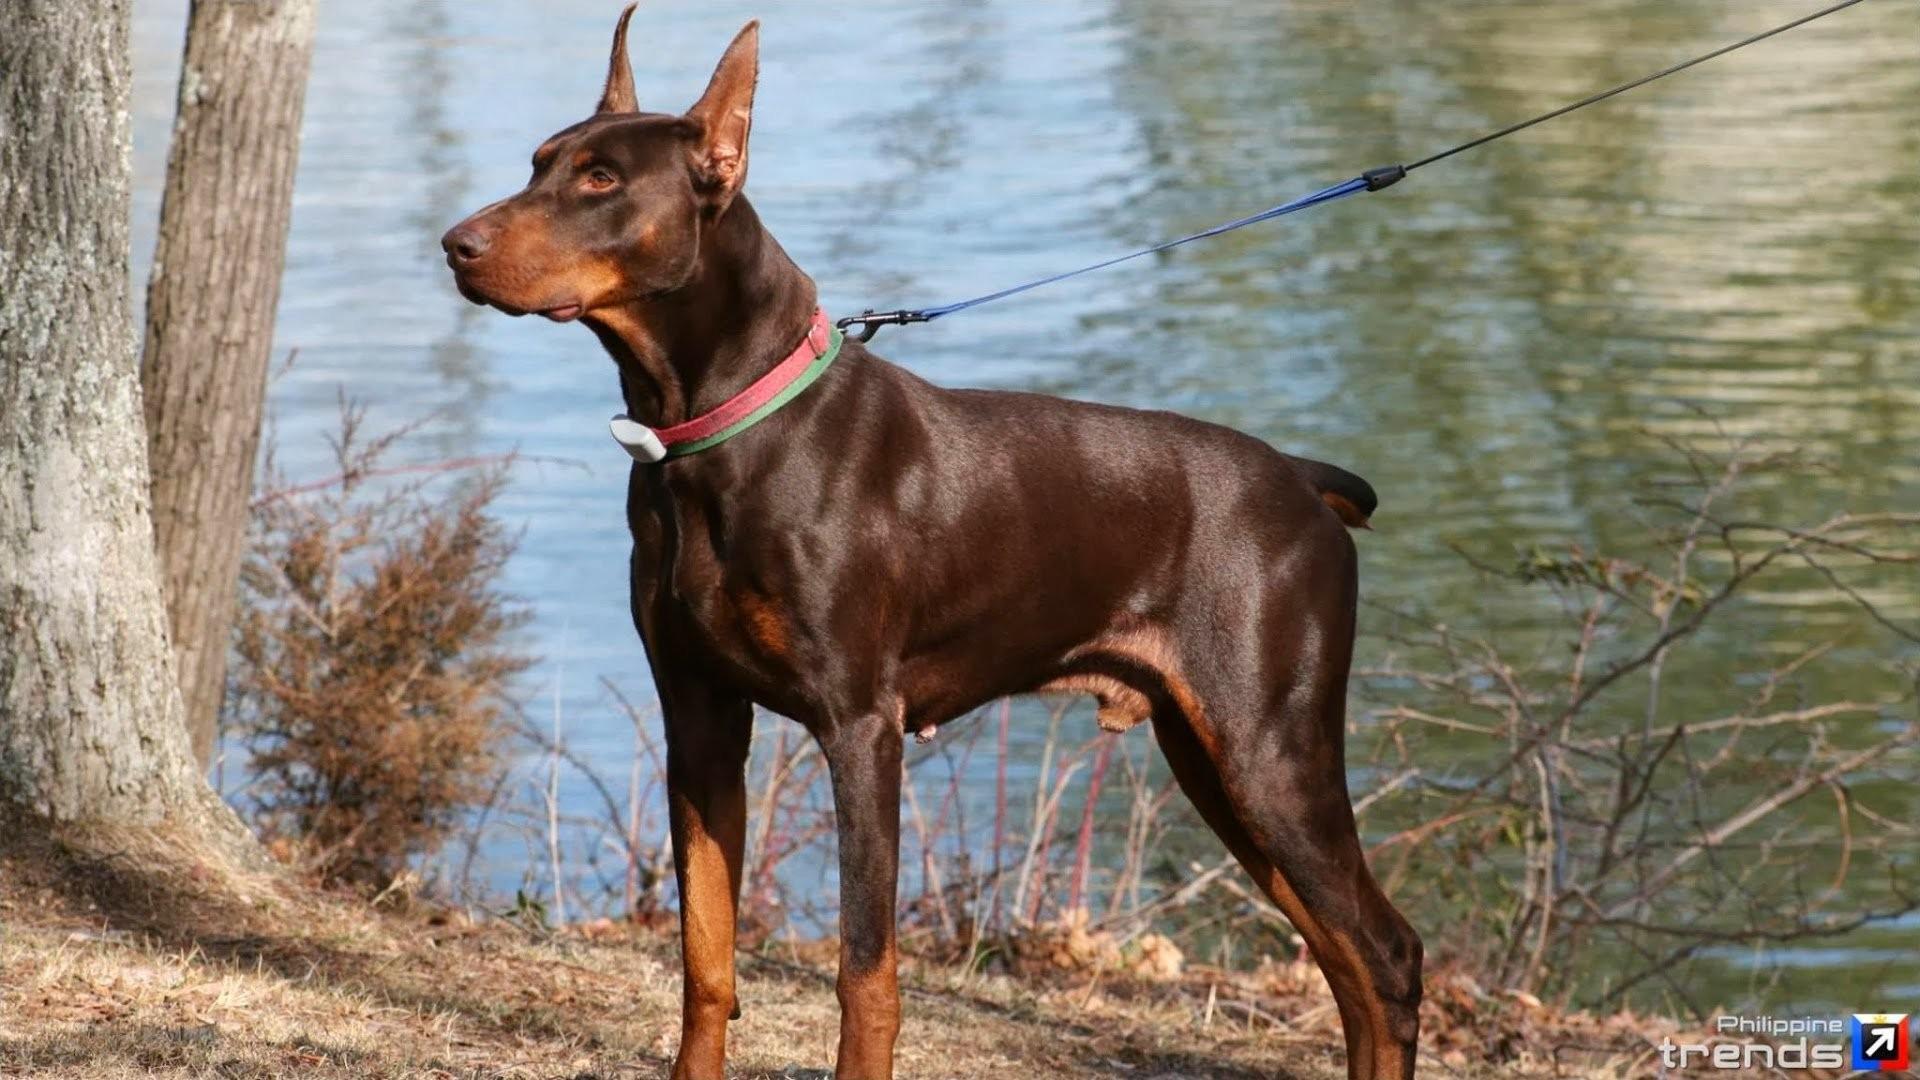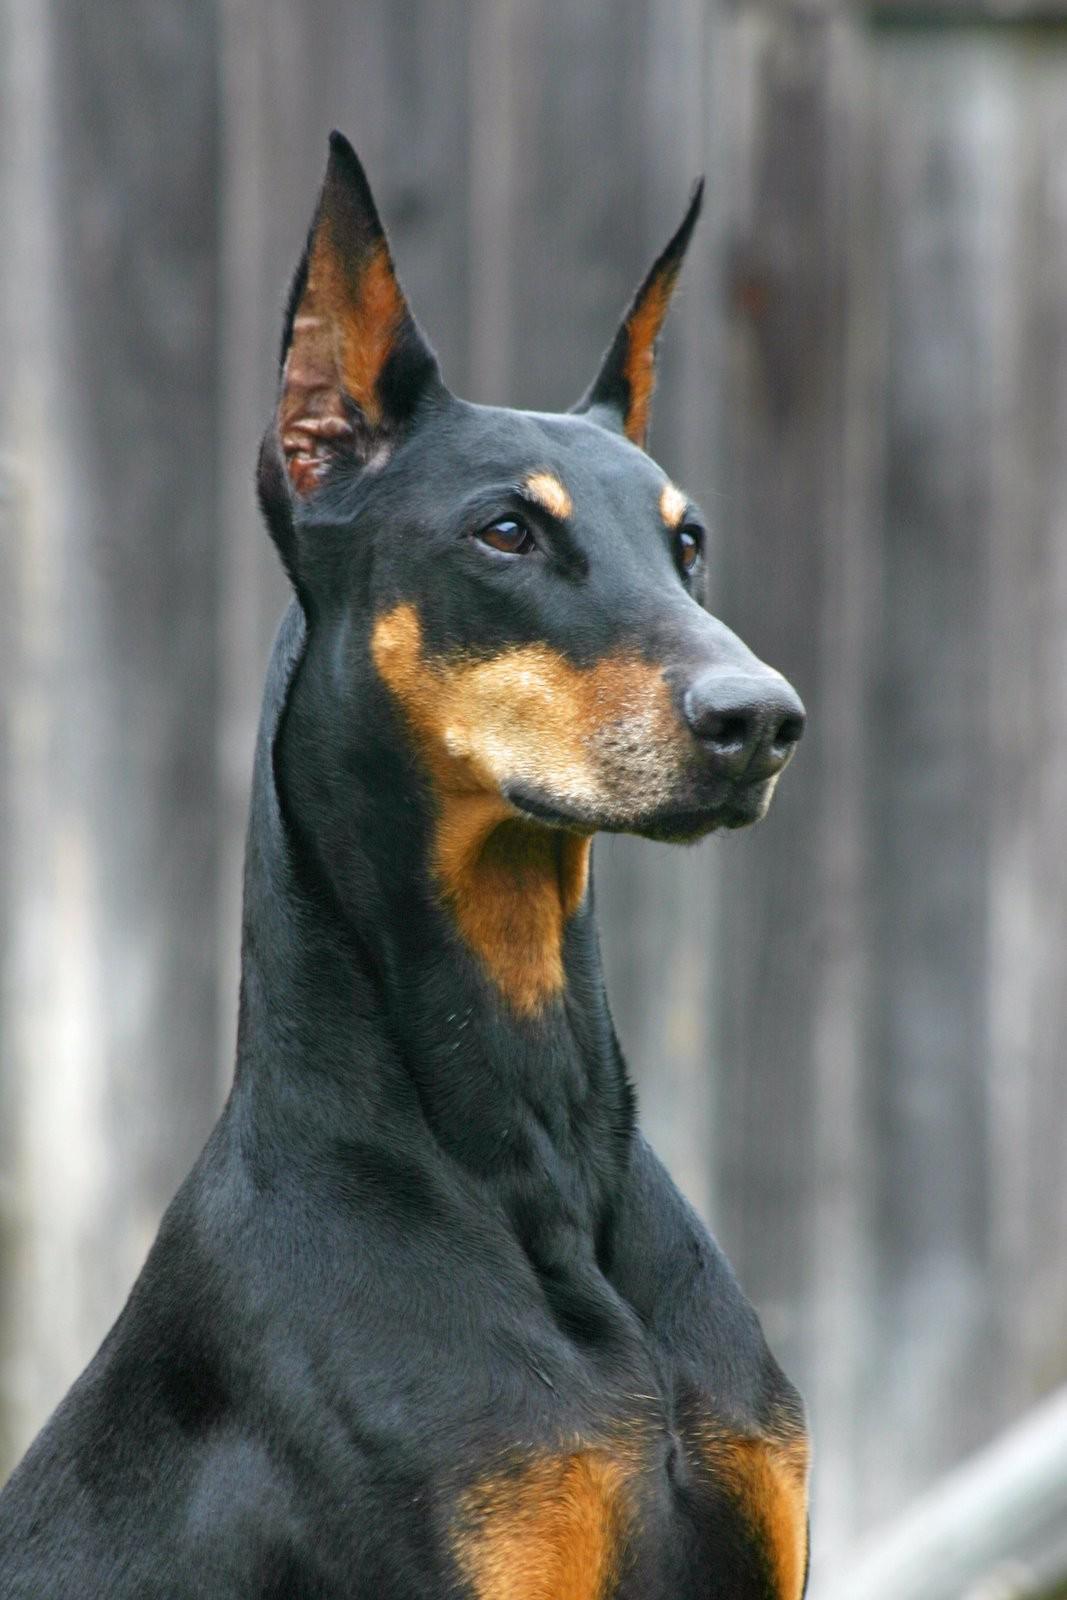The first image is the image on the left, the second image is the image on the right. Considering the images on both sides, is "there is a doberman with a taught leash attached to it's collar" valid? Answer yes or no. Yes. The first image is the image on the left, the second image is the image on the right. Assess this claim about the two images: "Each image contains one doberman with erect ears, and the left image features a doberman standing with its head and body angled leftward.". Correct or not? Answer yes or no. Yes. 